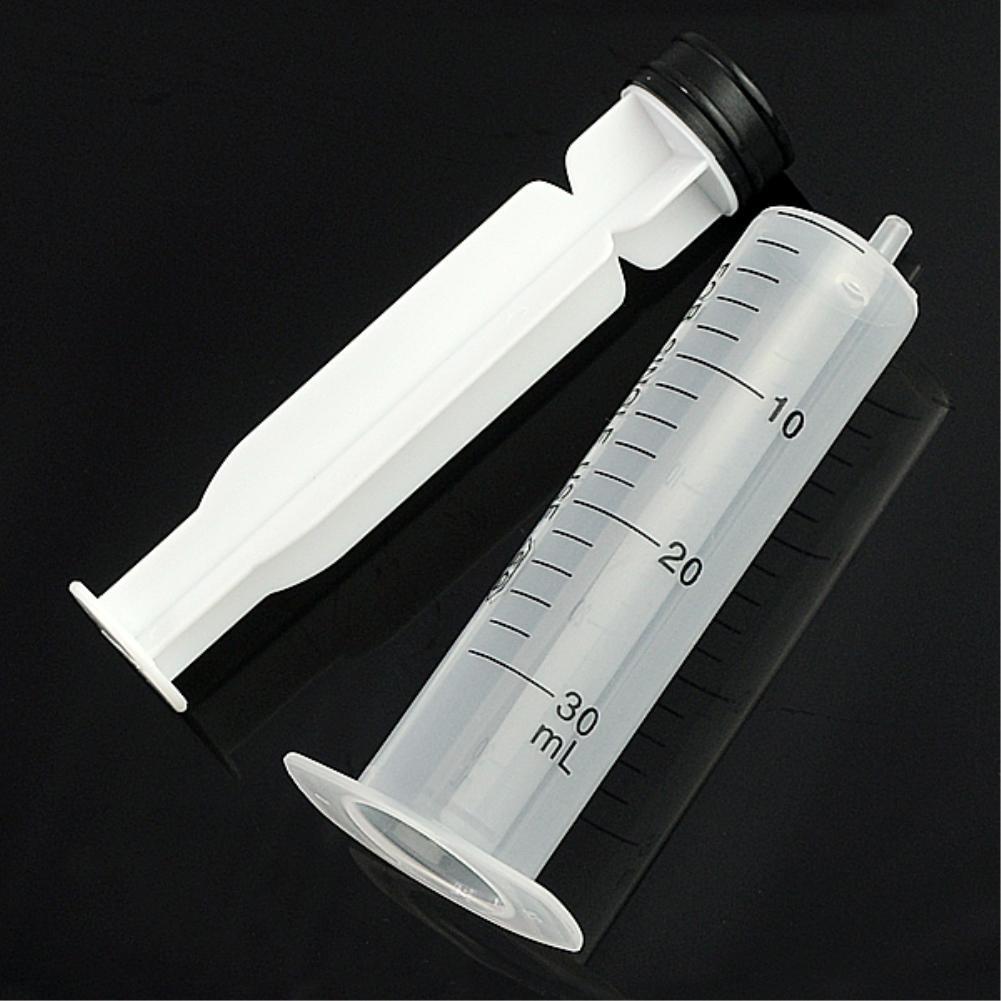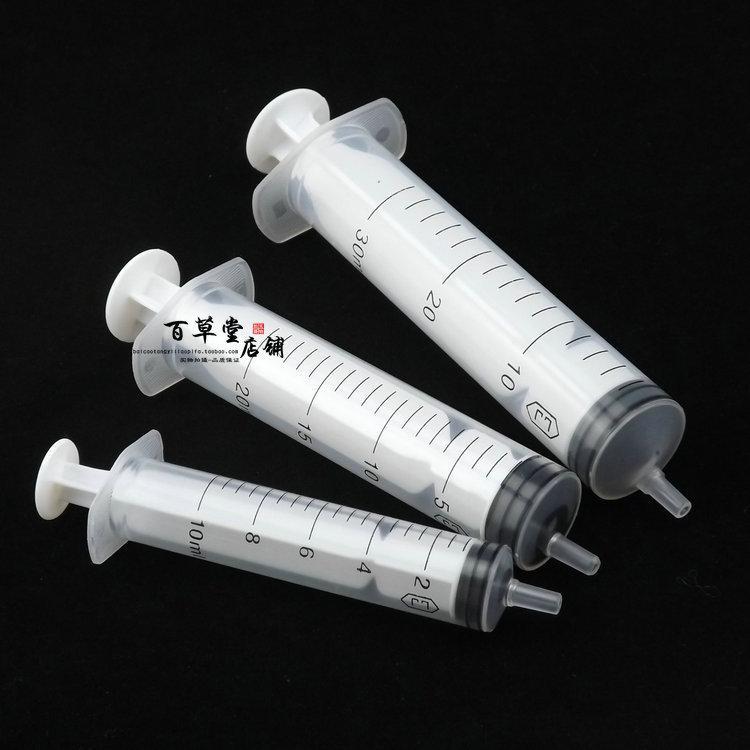The first image is the image on the left, the second image is the image on the right. Analyze the images presented: Is the assertion "At least one image contains exactly four syringes, and no image contains less than four syringes." valid? Answer yes or no. No. 